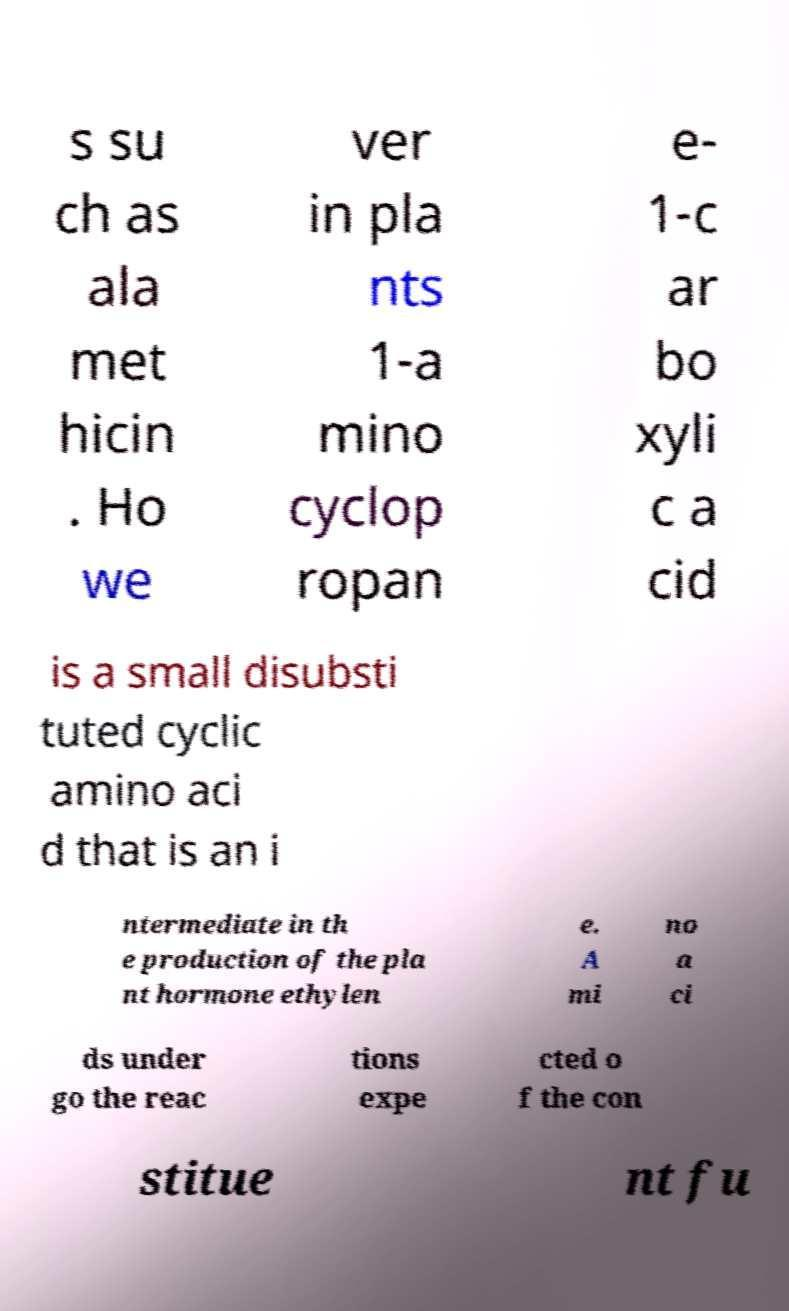Could you assist in decoding the text presented in this image and type it out clearly? s su ch as ala met hicin . Ho we ver in pla nts 1-a mino cyclop ropan e- 1-c ar bo xyli c a cid is a small disubsti tuted cyclic amino aci d that is an i ntermediate in th e production of the pla nt hormone ethylen e. A mi no a ci ds under go the reac tions expe cted o f the con stitue nt fu 